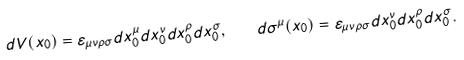<formula> <loc_0><loc_0><loc_500><loc_500>d V ( x _ { 0 } ) = \varepsilon _ { \mu \nu \rho \sigma } d x _ { 0 } ^ { \mu } d x _ { 0 } ^ { \nu } d x _ { 0 } ^ { \rho } d x _ { 0 } ^ { \sigma } , \quad d \sigma ^ { \mu } ( x _ { 0 } ) = \varepsilon _ { \mu \nu \rho \sigma } d x _ { 0 } ^ { \nu } d x _ { 0 } ^ { \rho } d x _ { 0 } ^ { \sigma } .</formula> 